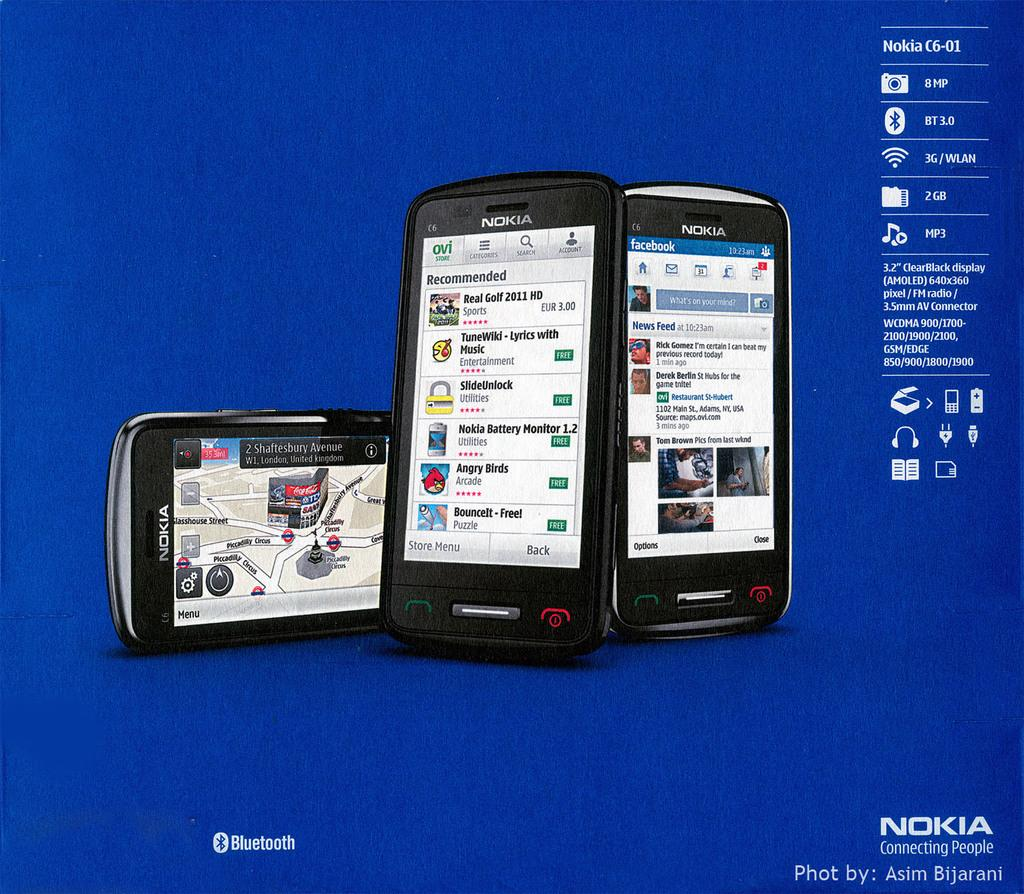<image>
Share a concise interpretation of the image provided. Nokia is the brand displayed on these three smart phones. 